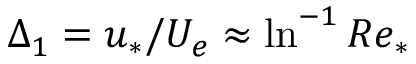Convert formula to latex. <formula><loc_0><loc_0><loc_500><loc_500>\Delta _ { 1 } = u _ { * } / U _ { e } \approx \ln ^ { - 1 } R e _ { * }</formula> 